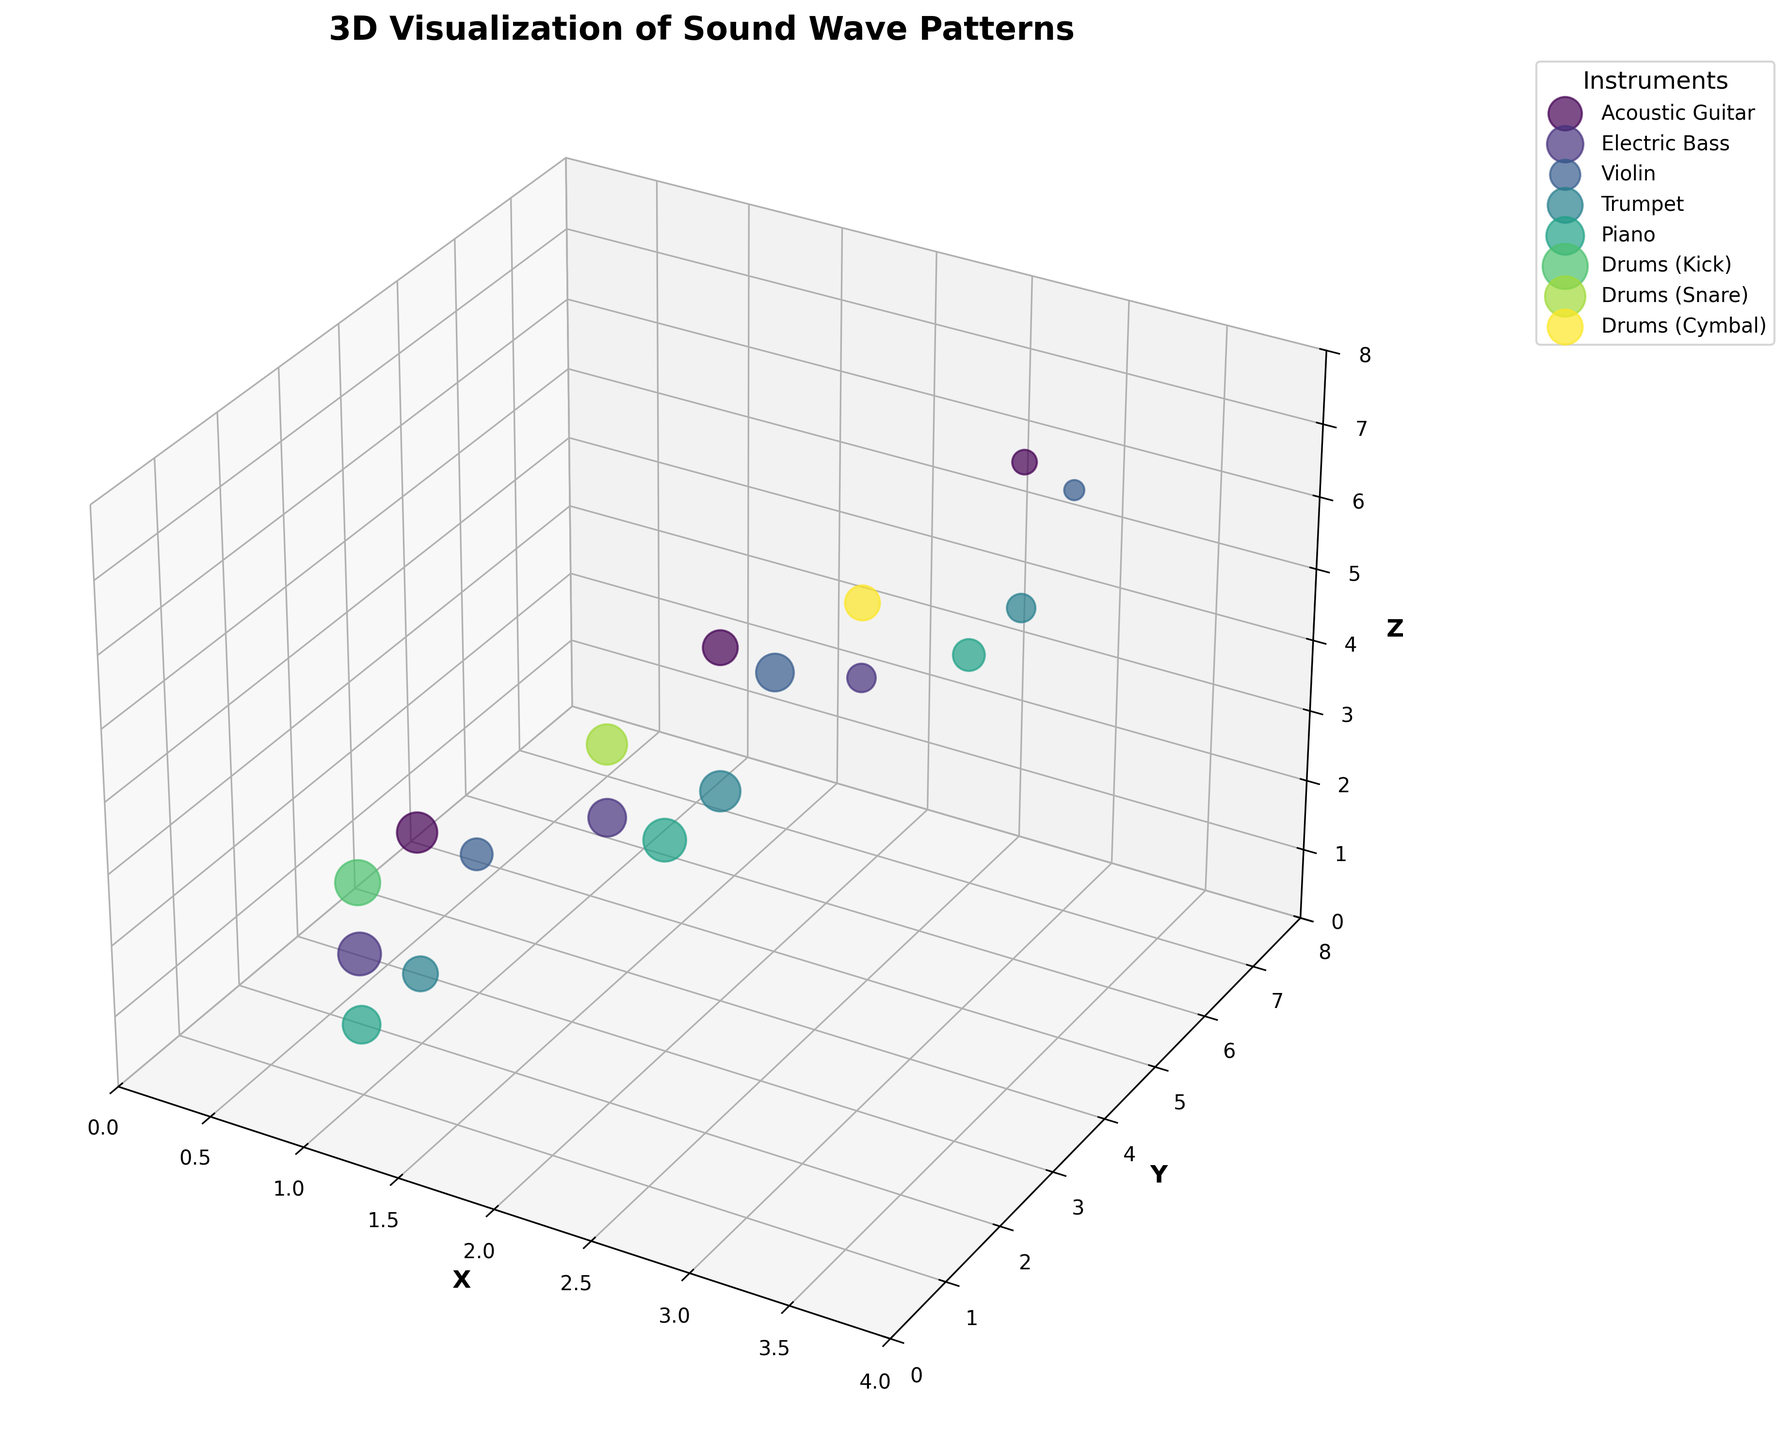What's the title of the figure? The title of the figure is displayed at the top of the plot. It is usually bold and larger than other text on the plot.
Answer: 3D Visualization of Sound Wave Patterns Which instrument has the highest amplitude, and what is its value? To find the highest amplitude, locate the largest data point. The biggest data point corresponds to "Drums (Kick)" with an amplitude of 1.0.
Answer: Drums (Kick), 1.0 How many data points are there for the Violin? Look for all the data points that have the label "Violin". Count them accurately.
Answer: 3 Which instrument shows data points at the maximum frequency, and what is that frequency? Identify the data point with the highest frequency value. Looking at the Z-axis, "Piano" shows the highest frequency, 4186 Hz.
Answer: Piano, 4186 Hz What's the total amplitude for the Acoustic Guitar across all its frequency ranges? Locate all the amplitude values for the Acoustic Guitar and sum them up (0.8 + 0.6 + 0.3). The total amplitude is 1.7.
Answer: 1.7 Which instrument's data points are closest to the origin (0,0,0) in the 3D space? Check the coordinates (X, Y, Z) and find the smallest values. "Piano" at (1,1,1) is closest to the origin.
Answer: Piano Which instrument has the smallest variation in amplitudes? Calculate the range (max-min) of amplitudes for each instrument. The smallest variation is for the violin (0.7 - 0.2 = 0.5).
Answer: Violin Which instrument data points can be found in the highest Y-axis range? Locate the highest Y values. The instrument with the highest Y value at 7 is "Violin".
Answer: Violin Compare the average amplitude of Electric Bass and Trumpet. Which is higher? Calculate the average amplitudes. Electric Bass: (0.9 + 0.7 + 0.4)/3 = 0.67. Trumpet: (0.6 + 0.8 + 0.4)/3 = 0.6. The bass has a higher average amplitude.
Answer: Electric Bass 